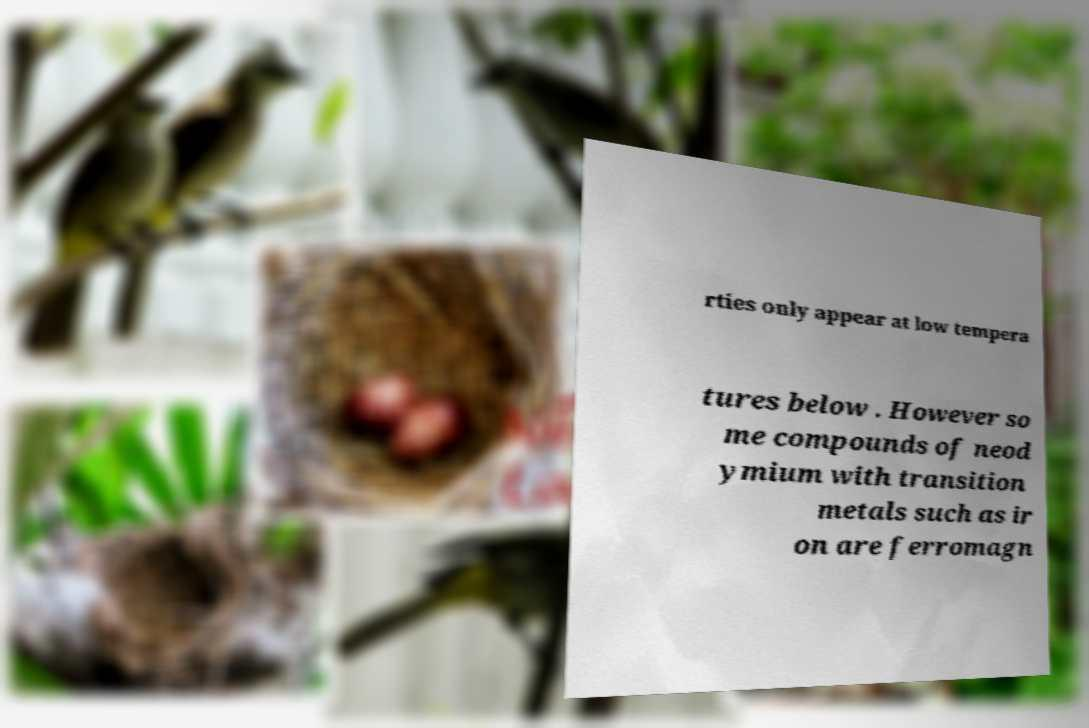Could you assist in decoding the text presented in this image and type it out clearly? rties only appear at low tempera tures below . However so me compounds of neod ymium with transition metals such as ir on are ferromagn 